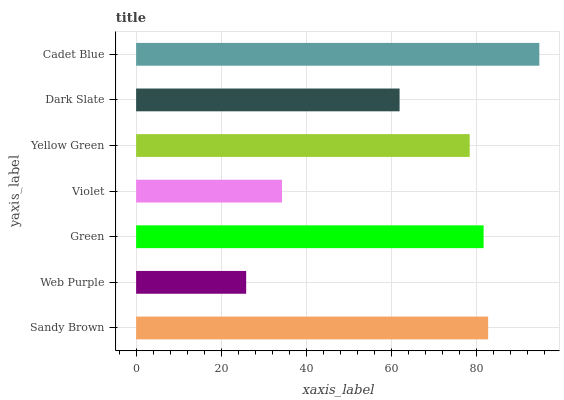Is Web Purple the minimum?
Answer yes or no. Yes. Is Cadet Blue the maximum?
Answer yes or no. Yes. Is Green the minimum?
Answer yes or no. No. Is Green the maximum?
Answer yes or no. No. Is Green greater than Web Purple?
Answer yes or no. Yes. Is Web Purple less than Green?
Answer yes or no. Yes. Is Web Purple greater than Green?
Answer yes or no. No. Is Green less than Web Purple?
Answer yes or no. No. Is Yellow Green the high median?
Answer yes or no. Yes. Is Yellow Green the low median?
Answer yes or no. Yes. Is Green the high median?
Answer yes or no. No. Is Sandy Brown the low median?
Answer yes or no. No. 